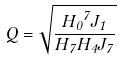Convert formula to latex. <formula><loc_0><loc_0><loc_500><loc_500>Q = \sqrt { \frac { { H _ { 0 } } ^ { 7 } J _ { 1 } } { H _ { 7 } H _ { 4 } J _ { 7 } } }</formula> 